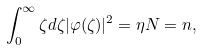Convert formula to latex. <formula><loc_0><loc_0><loc_500><loc_500>\int _ { 0 } ^ { \infty } \zeta d \zeta | \varphi ( \zeta ) | ^ { 2 } = \eta N = n ,</formula> 